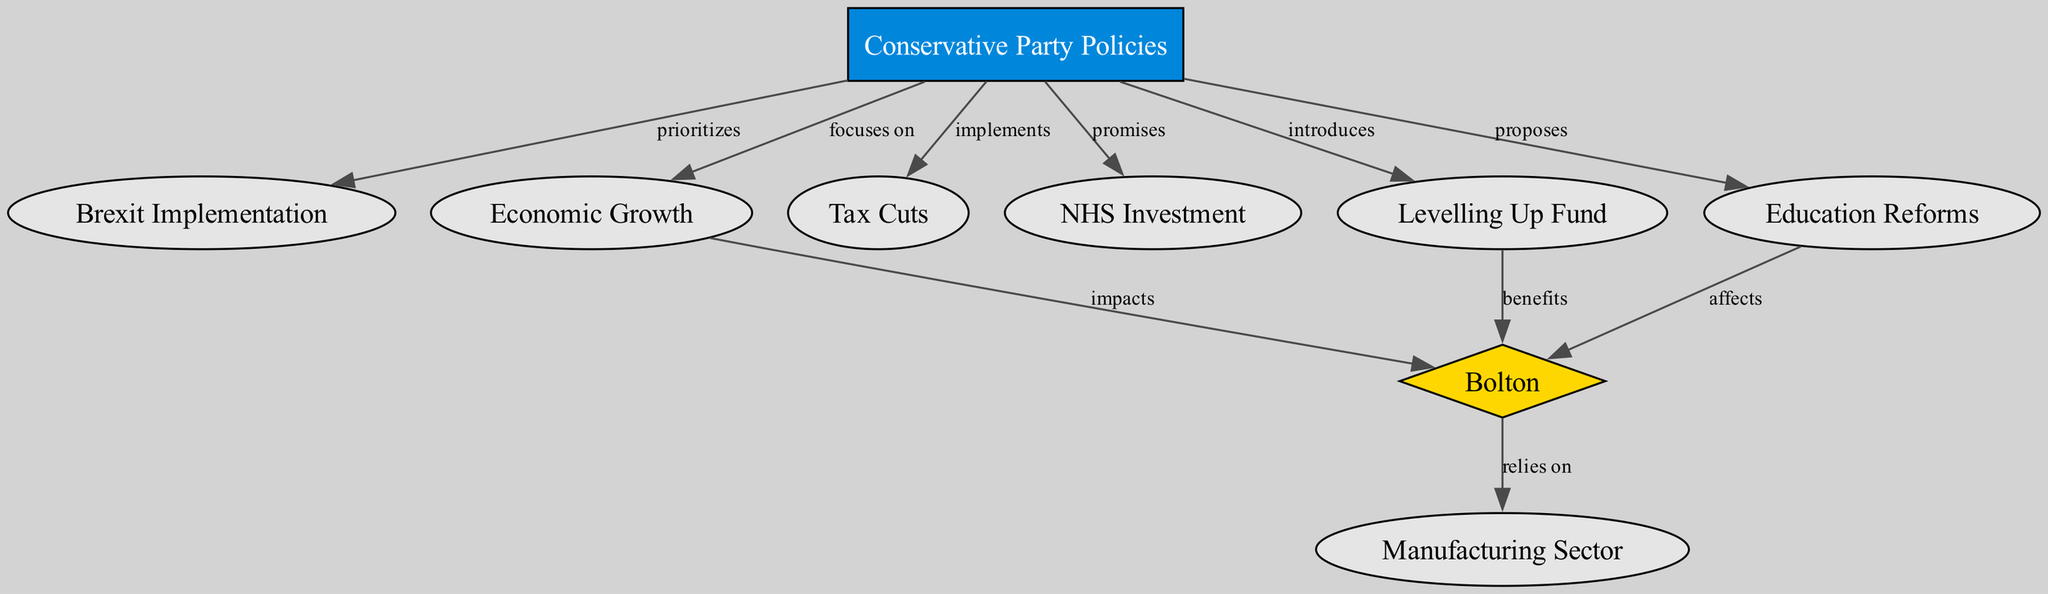What is the main focus of Conservative party policies? The diagram indicates that the main focus of Conservative party policies is on "Economic Growth." This is represented as one of the nodes that connects directly to the "Conservative Party Policies" node, showing its primary area of emphasis.
Answer: Economic Growth Which policy is prioritized by the Conservative party? According to the diagram, the policy that is prioritized by the Conservative party is "Brexit Implementation." This relationship is shown as a directed edge from "Conservative Party Policies" to "Brexit Implementation."
Answer: Brexit Implementation How many nodes are there in the diagram? Counting the individual items (nodes) presented in the diagram, there are a total of 9 nodes. This includes "Conservative Party Policies," "Brexit Implementation," "Economic Growth," "Tax Cuts," "NHS Investment," "Bolton," "Manufacturing Sector," "Levelling Up Fund," and "Education Reforms."
Answer: 9 What does Bolton rely on according to the diagram? The diagram indicates that Bolton relies on the "Manufacturing Sector." This relationship is depicted by a directed link flowing from "Bolton" to "Manufacturing Sector."
Answer: Manufacturing Sector How does the "Levelling Up Fund" affect Bolton? Based on the diagram, the "Levelling Up Fund" benefits Bolton. This is demonstrated by an edge that points from "Levelling Up Fund" to "Bolton," indicating a positive impact.
Answer: benefits What is the effect of education reforms on Bolton? The diagram states that education reforms affect Bolton. This connection is represented by an edge linking "Education Reforms" to "Bolton," implying that changes in education have implications for the area.
Answer: affects Which Conservative party policy introduces the "Levelling Up Fund"? The diagram reveals that "Conservative Party Policies" introduces the "Levelling Up Fund." This is indicated by a directed edge connecting the two nodes.
Answer: introduces How is the economy directly linked to Bolton? According to the diagram, the economy impacts Bolton. This is shown by a directed edge from "Economic Growth" to "Bolton," illustrating the influence of economic policies on the region.
Answer: impacts 